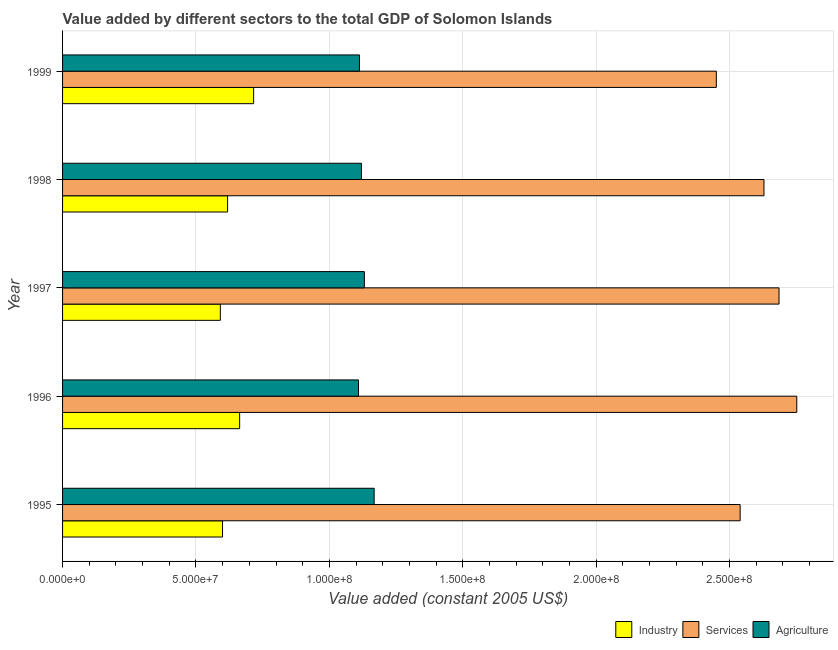How many different coloured bars are there?
Provide a short and direct response. 3. Are the number of bars per tick equal to the number of legend labels?
Provide a succinct answer. Yes. What is the value added by services in 1998?
Provide a succinct answer. 2.63e+08. Across all years, what is the maximum value added by services?
Offer a very short reply. 2.75e+08. Across all years, what is the minimum value added by services?
Your answer should be very brief. 2.45e+08. In which year was the value added by industrial sector maximum?
Provide a short and direct response. 1999. In which year was the value added by agricultural sector minimum?
Provide a succinct answer. 1996. What is the total value added by services in the graph?
Offer a terse response. 1.31e+09. What is the difference between the value added by industrial sector in 1995 and that in 1998?
Make the answer very short. -1.90e+06. What is the difference between the value added by services in 1998 and the value added by industrial sector in 1999?
Offer a terse response. 1.91e+08. What is the average value added by agricultural sector per year?
Give a very brief answer. 1.13e+08. In the year 1998, what is the difference between the value added by services and value added by agricultural sector?
Offer a terse response. 1.51e+08. In how many years, is the value added by agricultural sector greater than 200000000 US$?
Provide a succinct answer. 0. What is the ratio of the value added by industrial sector in 1996 to that in 1999?
Keep it short and to the point. 0.93. Is the difference between the value added by services in 1997 and 1999 greater than the difference between the value added by industrial sector in 1997 and 1999?
Your answer should be compact. Yes. What is the difference between the highest and the second highest value added by services?
Provide a short and direct response. 6.65e+06. What is the difference between the highest and the lowest value added by industrial sector?
Offer a terse response. 1.25e+07. In how many years, is the value added by agricultural sector greater than the average value added by agricultural sector taken over all years?
Offer a very short reply. 2. What does the 3rd bar from the top in 1997 represents?
Offer a terse response. Industry. What does the 1st bar from the bottom in 1997 represents?
Keep it short and to the point. Industry. Are all the bars in the graph horizontal?
Your answer should be compact. Yes. Are the values on the major ticks of X-axis written in scientific E-notation?
Offer a terse response. Yes. Does the graph contain any zero values?
Your answer should be compact. No. Does the graph contain grids?
Provide a succinct answer. Yes. Where does the legend appear in the graph?
Offer a terse response. Bottom right. What is the title of the graph?
Provide a short and direct response. Value added by different sectors to the total GDP of Solomon Islands. What is the label or title of the X-axis?
Keep it short and to the point. Value added (constant 2005 US$). What is the label or title of the Y-axis?
Make the answer very short. Year. What is the Value added (constant 2005 US$) of Industry in 1995?
Your answer should be very brief. 5.99e+07. What is the Value added (constant 2005 US$) in Services in 1995?
Make the answer very short. 2.54e+08. What is the Value added (constant 2005 US$) of Agriculture in 1995?
Make the answer very short. 1.17e+08. What is the Value added (constant 2005 US$) of Industry in 1996?
Provide a short and direct response. 6.64e+07. What is the Value added (constant 2005 US$) of Services in 1996?
Offer a very short reply. 2.75e+08. What is the Value added (constant 2005 US$) of Agriculture in 1996?
Provide a succinct answer. 1.11e+08. What is the Value added (constant 2005 US$) in Industry in 1997?
Your answer should be compact. 5.91e+07. What is the Value added (constant 2005 US$) in Services in 1997?
Offer a terse response. 2.69e+08. What is the Value added (constant 2005 US$) in Agriculture in 1997?
Offer a terse response. 1.13e+08. What is the Value added (constant 2005 US$) of Industry in 1998?
Provide a short and direct response. 6.18e+07. What is the Value added (constant 2005 US$) in Services in 1998?
Your answer should be compact. 2.63e+08. What is the Value added (constant 2005 US$) in Agriculture in 1998?
Keep it short and to the point. 1.12e+08. What is the Value added (constant 2005 US$) in Industry in 1999?
Offer a very short reply. 7.16e+07. What is the Value added (constant 2005 US$) of Services in 1999?
Keep it short and to the point. 2.45e+08. What is the Value added (constant 2005 US$) in Agriculture in 1999?
Keep it short and to the point. 1.11e+08. Across all years, what is the maximum Value added (constant 2005 US$) of Industry?
Your response must be concise. 7.16e+07. Across all years, what is the maximum Value added (constant 2005 US$) of Services?
Ensure brevity in your answer.  2.75e+08. Across all years, what is the maximum Value added (constant 2005 US$) of Agriculture?
Give a very brief answer. 1.17e+08. Across all years, what is the minimum Value added (constant 2005 US$) in Industry?
Provide a succinct answer. 5.91e+07. Across all years, what is the minimum Value added (constant 2005 US$) of Services?
Offer a very short reply. 2.45e+08. Across all years, what is the minimum Value added (constant 2005 US$) in Agriculture?
Make the answer very short. 1.11e+08. What is the total Value added (constant 2005 US$) of Industry in the graph?
Provide a succinct answer. 3.19e+08. What is the total Value added (constant 2005 US$) of Services in the graph?
Your answer should be compact. 1.31e+09. What is the total Value added (constant 2005 US$) in Agriculture in the graph?
Give a very brief answer. 5.64e+08. What is the difference between the Value added (constant 2005 US$) of Industry in 1995 and that in 1996?
Ensure brevity in your answer.  -6.42e+06. What is the difference between the Value added (constant 2005 US$) in Services in 1995 and that in 1996?
Ensure brevity in your answer.  -2.12e+07. What is the difference between the Value added (constant 2005 US$) of Agriculture in 1995 and that in 1996?
Give a very brief answer. 5.88e+06. What is the difference between the Value added (constant 2005 US$) of Industry in 1995 and that in 1997?
Your answer should be compact. 8.14e+05. What is the difference between the Value added (constant 2005 US$) in Services in 1995 and that in 1997?
Offer a very short reply. -1.46e+07. What is the difference between the Value added (constant 2005 US$) in Agriculture in 1995 and that in 1997?
Give a very brief answer. 3.67e+06. What is the difference between the Value added (constant 2005 US$) of Industry in 1995 and that in 1998?
Your answer should be very brief. -1.90e+06. What is the difference between the Value added (constant 2005 US$) in Services in 1995 and that in 1998?
Ensure brevity in your answer.  -8.93e+06. What is the difference between the Value added (constant 2005 US$) in Agriculture in 1995 and that in 1998?
Give a very brief answer. 4.77e+06. What is the difference between the Value added (constant 2005 US$) of Industry in 1995 and that in 1999?
Keep it short and to the point. -1.17e+07. What is the difference between the Value added (constant 2005 US$) of Services in 1995 and that in 1999?
Give a very brief answer. 8.93e+06. What is the difference between the Value added (constant 2005 US$) of Agriculture in 1995 and that in 1999?
Provide a succinct answer. 5.51e+06. What is the difference between the Value added (constant 2005 US$) of Industry in 1996 and that in 1997?
Give a very brief answer. 7.23e+06. What is the difference between the Value added (constant 2005 US$) in Services in 1996 and that in 1997?
Ensure brevity in your answer.  6.65e+06. What is the difference between the Value added (constant 2005 US$) of Agriculture in 1996 and that in 1997?
Provide a short and direct response. -2.20e+06. What is the difference between the Value added (constant 2005 US$) of Industry in 1996 and that in 1998?
Give a very brief answer. 4.52e+06. What is the difference between the Value added (constant 2005 US$) of Services in 1996 and that in 1998?
Provide a short and direct response. 1.23e+07. What is the difference between the Value added (constant 2005 US$) of Agriculture in 1996 and that in 1998?
Your answer should be very brief. -1.10e+06. What is the difference between the Value added (constant 2005 US$) of Industry in 1996 and that in 1999?
Give a very brief answer. -5.24e+06. What is the difference between the Value added (constant 2005 US$) in Services in 1996 and that in 1999?
Keep it short and to the point. 3.02e+07. What is the difference between the Value added (constant 2005 US$) in Agriculture in 1996 and that in 1999?
Keep it short and to the point. -3.67e+05. What is the difference between the Value added (constant 2005 US$) in Industry in 1997 and that in 1998?
Give a very brief answer. -2.71e+06. What is the difference between the Value added (constant 2005 US$) of Services in 1997 and that in 1998?
Your answer should be compact. 5.64e+06. What is the difference between the Value added (constant 2005 US$) in Agriculture in 1997 and that in 1998?
Offer a terse response. 1.10e+06. What is the difference between the Value added (constant 2005 US$) in Industry in 1997 and that in 1999?
Give a very brief answer. -1.25e+07. What is the difference between the Value added (constant 2005 US$) in Services in 1997 and that in 1999?
Keep it short and to the point. 2.35e+07. What is the difference between the Value added (constant 2005 US$) of Agriculture in 1997 and that in 1999?
Make the answer very short. 1.84e+06. What is the difference between the Value added (constant 2005 US$) of Industry in 1998 and that in 1999?
Keep it short and to the point. -9.77e+06. What is the difference between the Value added (constant 2005 US$) of Services in 1998 and that in 1999?
Offer a very short reply. 1.79e+07. What is the difference between the Value added (constant 2005 US$) of Agriculture in 1998 and that in 1999?
Provide a short and direct response. 7.35e+05. What is the difference between the Value added (constant 2005 US$) in Industry in 1995 and the Value added (constant 2005 US$) in Services in 1996?
Your response must be concise. -2.15e+08. What is the difference between the Value added (constant 2005 US$) of Industry in 1995 and the Value added (constant 2005 US$) of Agriculture in 1996?
Your answer should be very brief. -5.10e+07. What is the difference between the Value added (constant 2005 US$) in Services in 1995 and the Value added (constant 2005 US$) in Agriculture in 1996?
Provide a succinct answer. 1.43e+08. What is the difference between the Value added (constant 2005 US$) in Industry in 1995 and the Value added (constant 2005 US$) in Services in 1997?
Give a very brief answer. -2.09e+08. What is the difference between the Value added (constant 2005 US$) of Industry in 1995 and the Value added (constant 2005 US$) of Agriculture in 1997?
Provide a short and direct response. -5.32e+07. What is the difference between the Value added (constant 2005 US$) of Services in 1995 and the Value added (constant 2005 US$) of Agriculture in 1997?
Make the answer very short. 1.41e+08. What is the difference between the Value added (constant 2005 US$) of Industry in 1995 and the Value added (constant 2005 US$) of Services in 1998?
Offer a very short reply. -2.03e+08. What is the difference between the Value added (constant 2005 US$) in Industry in 1995 and the Value added (constant 2005 US$) in Agriculture in 1998?
Give a very brief answer. -5.21e+07. What is the difference between the Value added (constant 2005 US$) of Services in 1995 and the Value added (constant 2005 US$) of Agriculture in 1998?
Offer a very short reply. 1.42e+08. What is the difference between the Value added (constant 2005 US$) in Industry in 1995 and the Value added (constant 2005 US$) in Services in 1999?
Provide a succinct answer. -1.85e+08. What is the difference between the Value added (constant 2005 US$) in Industry in 1995 and the Value added (constant 2005 US$) in Agriculture in 1999?
Give a very brief answer. -5.13e+07. What is the difference between the Value added (constant 2005 US$) of Services in 1995 and the Value added (constant 2005 US$) of Agriculture in 1999?
Provide a succinct answer. 1.43e+08. What is the difference between the Value added (constant 2005 US$) in Industry in 1996 and the Value added (constant 2005 US$) in Services in 1997?
Ensure brevity in your answer.  -2.02e+08. What is the difference between the Value added (constant 2005 US$) of Industry in 1996 and the Value added (constant 2005 US$) of Agriculture in 1997?
Your answer should be compact. -4.67e+07. What is the difference between the Value added (constant 2005 US$) of Services in 1996 and the Value added (constant 2005 US$) of Agriculture in 1997?
Keep it short and to the point. 1.62e+08. What is the difference between the Value added (constant 2005 US$) in Industry in 1996 and the Value added (constant 2005 US$) in Services in 1998?
Your response must be concise. -1.97e+08. What is the difference between the Value added (constant 2005 US$) of Industry in 1996 and the Value added (constant 2005 US$) of Agriculture in 1998?
Your answer should be very brief. -4.56e+07. What is the difference between the Value added (constant 2005 US$) of Services in 1996 and the Value added (constant 2005 US$) of Agriculture in 1998?
Provide a succinct answer. 1.63e+08. What is the difference between the Value added (constant 2005 US$) in Industry in 1996 and the Value added (constant 2005 US$) in Services in 1999?
Offer a terse response. -1.79e+08. What is the difference between the Value added (constant 2005 US$) in Industry in 1996 and the Value added (constant 2005 US$) in Agriculture in 1999?
Make the answer very short. -4.49e+07. What is the difference between the Value added (constant 2005 US$) of Services in 1996 and the Value added (constant 2005 US$) of Agriculture in 1999?
Ensure brevity in your answer.  1.64e+08. What is the difference between the Value added (constant 2005 US$) of Industry in 1997 and the Value added (constant 2005 US$) of Services in 1998?
Your response must be concise. -2.04e+08. What is the difference between the Value added (constant 2005 US$) in Industry in 1997 and the Value added (constant 2005 US$) in Agriculture in 1998?
Ensure brevity in your answer.  -5.29e+07. What is the difference between the Value added (constant 2005 US$) in Services in 1997 and the Value added (constant 2005 US$) in Agriculture in 1998?
Your response must be concise. 1.57e+08. What is the difference between the Value added (constant 2005 US$) of Industry in 1997 and the Value added (constant 2005 US$) of Services in 1999?
Offer a terse response. -1.86e+08. What is the difference between the Value added (constant 2005 US$) in Industry in 1997 and the Value added (constant 2005 US$) in Agriculture in 1999?
Your response must be concise. -5.21e+07. What is the difference between the Value added (constant 2005 US$) in Services in 1997 and the Value added (constant 2005 US$) in Agriculture in 1999?
Your answer should be compact. 1.57e+08. What is the difference between the Value added (constant 2005 US$) in Industry in 1998 and the Value added (constant 2005 US$) in Services in 1999?
Your answer should be compact. -1.83e+08. What is the difference between the Value added (constant 2005 US$) of Industry in 1998 and the Value added (constant 2005 US$) of Agriculture in 1999?
Your answer should be compact. -4.94e+07. What is the difference between the Value added (constant 2005 US$) of Services in 1998 and the Value added (constant 2005 US$) of Agriculture in 1999?
Give a very brief answer. 1.52e+08. What is the average Value added (constant 2005 US$) in Industry per year?
Provide a short and direct response. 6.38e+07. What is the average Value added (constant 2005 US$) in Services per year?
Ensure brevity in your answer.  2.61e+08. What is the average Value added (constant 2005 US$) in Agriculture per year?
Offer a terse response. 1.13e+08. In the year 1995, what is the difference between the Value added (constant 2005 US$) of Industry and Value added (constant 2005 US$) of Services?
Offer a terse response. -1.94e+08. In the year 1995, what is the difference between the Value added (constant 2005 US$) in Industry and Value added (constant 2005 US$) in Agriculture?
Provide a short and direct response. -5.68e+07. In the year 1995, what is the difference between the Value added (constant 2005 US$) in Services and Value added (constant 2005 US$) in Agriculture?
Make the answer very short. 1.37e+08. In the year 1996, what is the difference between the Value added (constant 2005 US$) of Industry and Value added (constant 2005 US$) of Services?
Offer a terse response. -2.09e+08. In the year 1996, what is the difference between the Value added (constant 2005 US$) of Industry and Value added (constant 2005 US$) of Agriculture?
Your answer should be compact. -4.45e+07. In the year 1996, what is the difference between the Value added (constant 2005 US$) in Services and Value added (constant 2005 US$) in Agriculture?
Offer a terse response. 1.64e+08. In the year 1997, what is the difference between the Value added (constant 2005 US$) in Industry and Value added (constant 2005 US$) in Services?
Your answer should be compact. -2.09e+08. In the year 1997, what is the difference between the Value added (constant 2005 US$) in Industry and Value added (constant 2005 US$) in Agriculture?
Offer a very short reply. -5.40e+07. In the year 1997, what is the difference between the Value added (constant 2005 US$) of Services and Value added (constant 2005 US$) of Agriculture?
Offer a very short reply. 1.55e+08. In the year 1998, what is the difference between the Value added (constant 2005 US$) in Industry and Value added (constant 2005 US$) in Services?
Your response must be concise. -2.01e+08. In the year 1998, what is the difference between the Value added (constant 2005 US$) in Industry and Value added (constant 2005 US$) in Agriculture?
Ensure brevity in your answer.  -5.02e+07. In the year 1998, what is the difference between the Value added (constant 2005 US$) in Services and Value added (constant 2005 US$) in Agriculture?
Offer a very short reply. 1.51e+08. In the year 1999, what is the difference between the Value added (constant 2005 US$) in Industry and Value added (constant 2005 US$) in Services?
Your answer should be compact. -1.73e+08. In the year 1999, what is the difference between the Value added (constant 2005 US$) in Industry and Value added (constant 2005 US$) in Agriculture?
Ensure brevity in your answer.  -3.97e+07. In the year 1999, what is the difference between the Value added (constant 2005 US$) of Services and Value added (constant 2005 US$) of Agriculture?
Offer a terse response. 1.34e+08. What is the ratio of the Value added (constant 2005 US$) in Industry in 1995 to that in 1996?
Provide a succinct answer. 0.9. What is the ratio of the Value added (constant 2005 US$) of Services in 1995 to that in 1996?
Your answer should be very brief. 0.92. What is the ratio of the Value added (constant 2005 US$) in Agriculture in 1995 to that in 1996?
Make the answer very short. 1.05. What is the ratio of the Value added (constant 2005 US$) of Industry in 1995 to that in 1997?
Keep it short and to the point. 1.01. What is the ratio of the Value added (constant 2005 US$) of Services in 1995 to that in 1997?
Provide a short and direct response. 0.95. What is the ratio of the Value added (constant 2005 US$) of Agriculture in 1995 to that in 1997?
Offer a very short reply. 1.03. What is the ratio of the Value added (constant 2005 US$) in Industry in 1995 to that in 1998?
Provide a succinct answer. 0.97. What is the ratio of the Value added (constant 2005 US$) in Agriculture in 1995 to that in 1998?
Your answer should be very brief. 1.04. What is the ratio of the Value added (constant 2005 US$) of Industry in 1995 to that in 1999?
Make the answer very short. 0.84. What is the ratio of the Value added (constant 2005 US$) in Services in 1995 to that in 1999?
Provide a succinct answer. 1.04. What is the ratio of the Value added (constant 2005 US$) of Agriculture in 1995 to that in 1999?
Your answer should be compact. 1.05. What is the ratio of the Value added (constant 2005 US$) in Industry in 1996 to that in 1997?
Provide a short and direct response. 1.12. What is the ratio of the Value added (constant 2005 US$) in Services in 1996 to that in 1997?
Offer a very short reply. 1.02. What is the ratio of the Value added (constant 2005 US$) of Agriculture in 1996 to that in 1997?
Give a very brief answer. 0.98. What is the ratio of the Value added (constant 2005 US$) of Industry in 1996 to that in 1998?
Keep it short and to the point. 1.07. What is the ratio of the Value added (constant 2005 US$) in Services in 1996 to that in 1998?
Give a very brief answer. 1.05. What is the ratio of the Value added (constant 2005 US$) of Agriculture in 1996 to that in 1998?
Make the answer very short. 0.99. What is the ratio of the Value added (constant 2005 US$) in Industry in 1996 to that in 1999?
Keep it short and to the point. 0.93. What is the ratio of the Value added (constant 2005 US$) of Services in 1996 to that in 1999?
Provide a short and direct response. 1.12. What is the ratio of the Value added (constant 2005 US$) in Industry in 1997 to that in 1998?
Ensure brevity in your answer.  0.96. What is the ratio of the Value added (constant 2005 US$) of Services in 1997 to that in 1998?
Make the answer very short. 1.02. What is the ratio of the Value added (constant 2005 US$) of Agriculture in 1997 to that in 1998?
Ensure brevity in your answer.  1.01. What is the ratio of the Value added (constant 2005 US$) in Industry in 1997 to that in 1999?
Offer a terse response. 0.83. What is the ratio of the Value added (constant 2005 US$) of Services in 1997 to that in 1999?
Make the answer very short. 1.1. What is the ratio of the Value added (constant 2005 US$) of Agriculture in 1997 to that in 1999?
Your response must be concise. 1.02. What is the ratio of the Value added (constant 2005 US$) in Industry in 1998 to that in 1999?
Keep it short and to the point. 0.86. What is the ratio of the Value added (constant 2005 US$) in Services in 1998 to that in 1999?
Your answer should be compact. 1.07. What is the ratio of the Value added (constant 2005 US$) in Agriculture in 1998 to that in 1999?
Provide a short and direct response. 1.01. What is the difference between the highest and the second highest Value added (constant 2005 US$) of Industry?
Your response must be concise. 5.24e+06. What is the difference between the highest and the second highest Value added (constant 2005 US$) in Services?
Offer a very short reply. 6.65e+06. What is the difference between the highest and the second highest Value added (constant 2005 US$) of Agriculture?
Provide a short and direct response. 3.67e+06. What is the difference between the highest and the lowest Value added (constant 2005 US$) in Industry?
Your response must be concise. 1.25e+07. What is the difference between the highest and the lowest Value added (constant 2005 US$) in Services?
Ensure brevity in your answer.  3.02e+07. What is the difference between the highest and the lowest Value added (constant 2005 US$) in Agriculture?
Make the answer very short. 5.88e+06. 